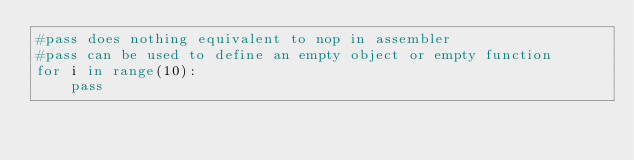Convert code to text. <code><loc_0><loc_0><loc_500><loc_500><_Python_>#pass does nothing equivalent to nop in assembler
#pass can be used to define an empty object or empty function
for i in range(10):
    pass</code> 